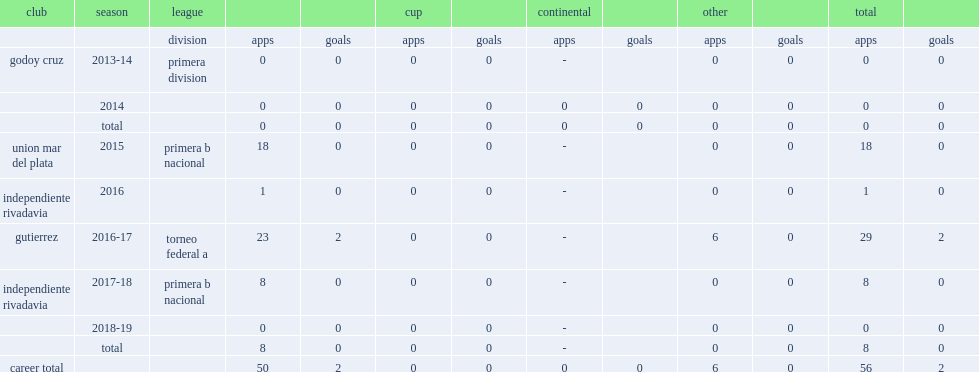In 2015, which division did barrera appear for the union mar del plata? Primera b nacional. 